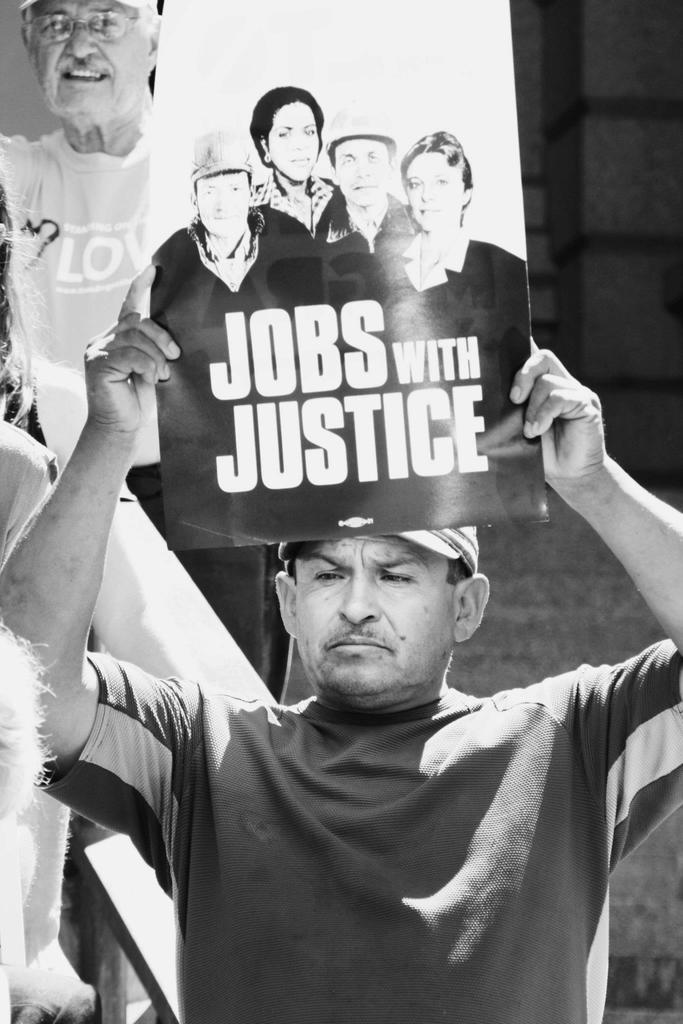What is the person in the image holding? The person in the image is holding a poster. Can you describe the background of the image? Few people are visible in the background of the image. What type of kitten can be seen playing with butter in the image? There is no kitten or butter present in the image; it only features a person holding a poster and a few people in the background. 